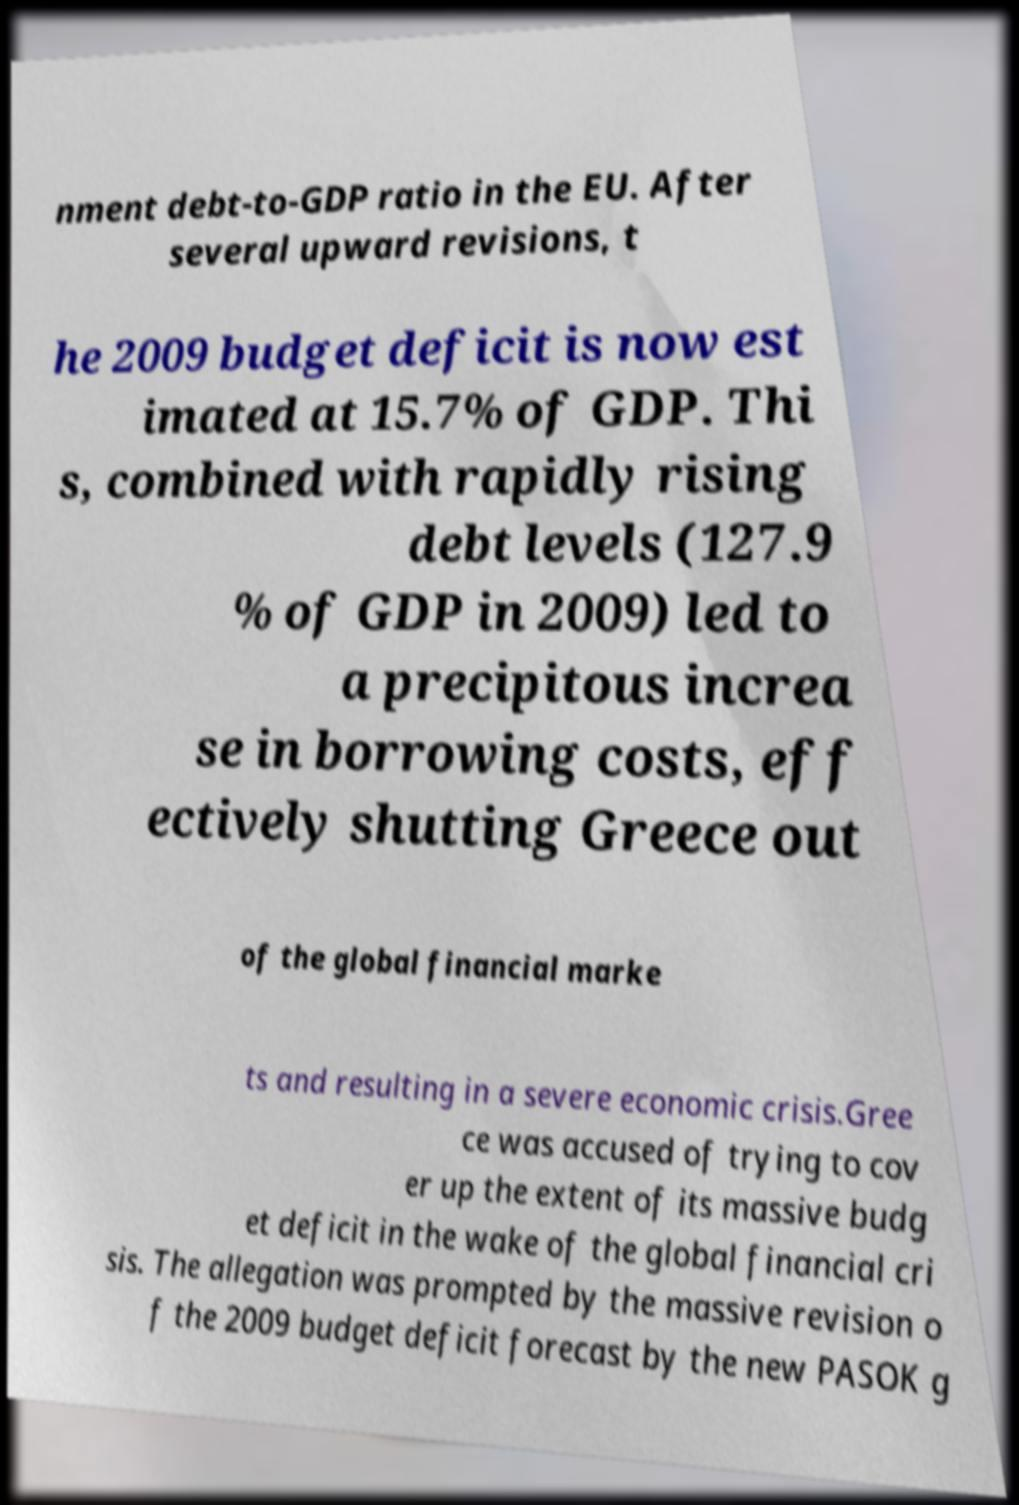There's text embedded in this image that I need extracted. Can you transcribe it verbatim? nment debt-to-GDP ratio in the EU. After several upward revisions, t he 2009 budget deficit is now est imated at 15.7% of GDP. Thi s, combined with rapidly rising debt levels (127.9 % of GDP in 2009) led to a precipitous increa se in borrowing costs, eff ectively shutting Greece out of the global financial marke ts and resulting in a severe economic crisis.Gree ce was accused of trying to cov er up the extent of its massive budg et deficit in the wake of the global financial cri sis. The allegation was prompted by the massive revision o f the 2009 budget deficit forecast by the new PASOK g 